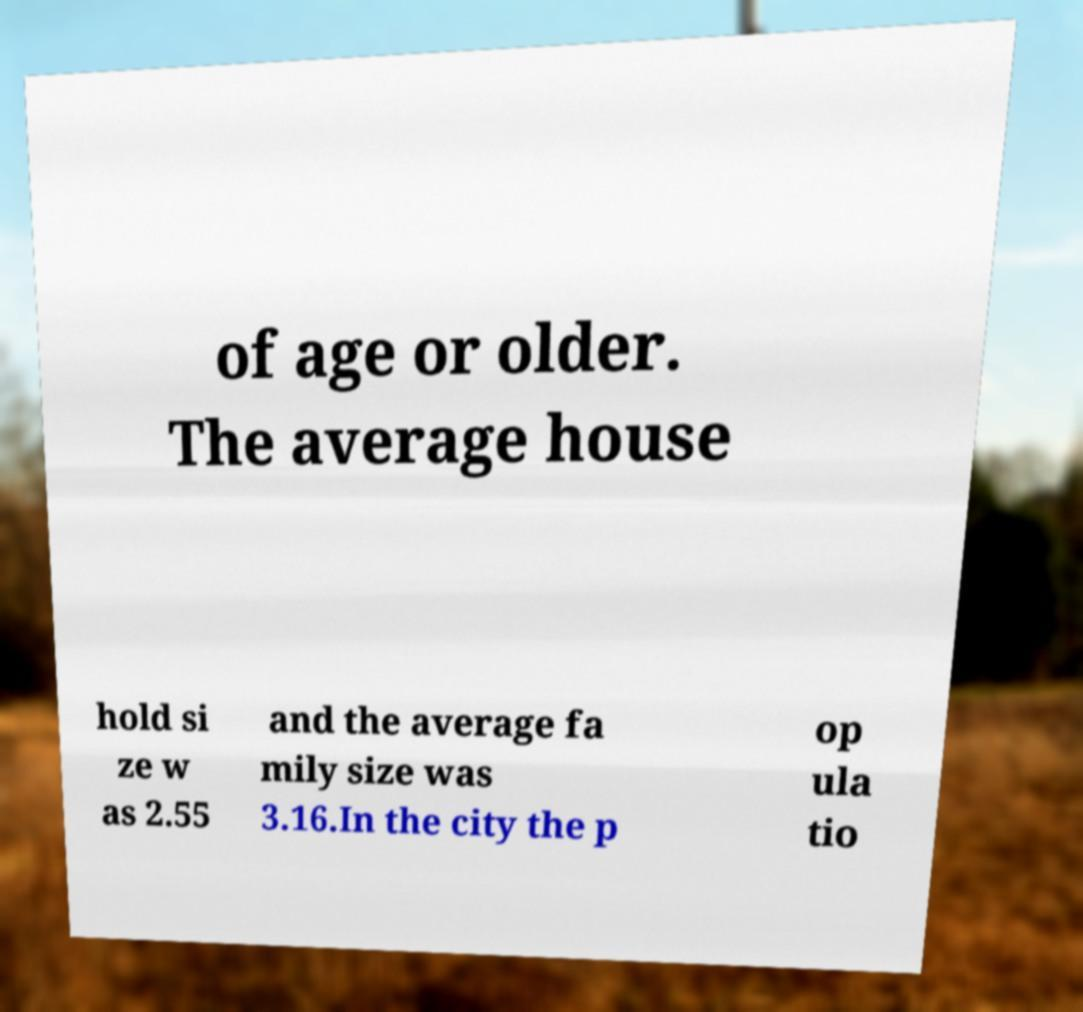Can you read and provide the text displayed in the image?This photo seems to have some interesting text. Can you extract and type it out for me? of age or older. The average house hold si ze w as 2.55 and the average fa mily size was 3.16.In the city the p op ula tio 